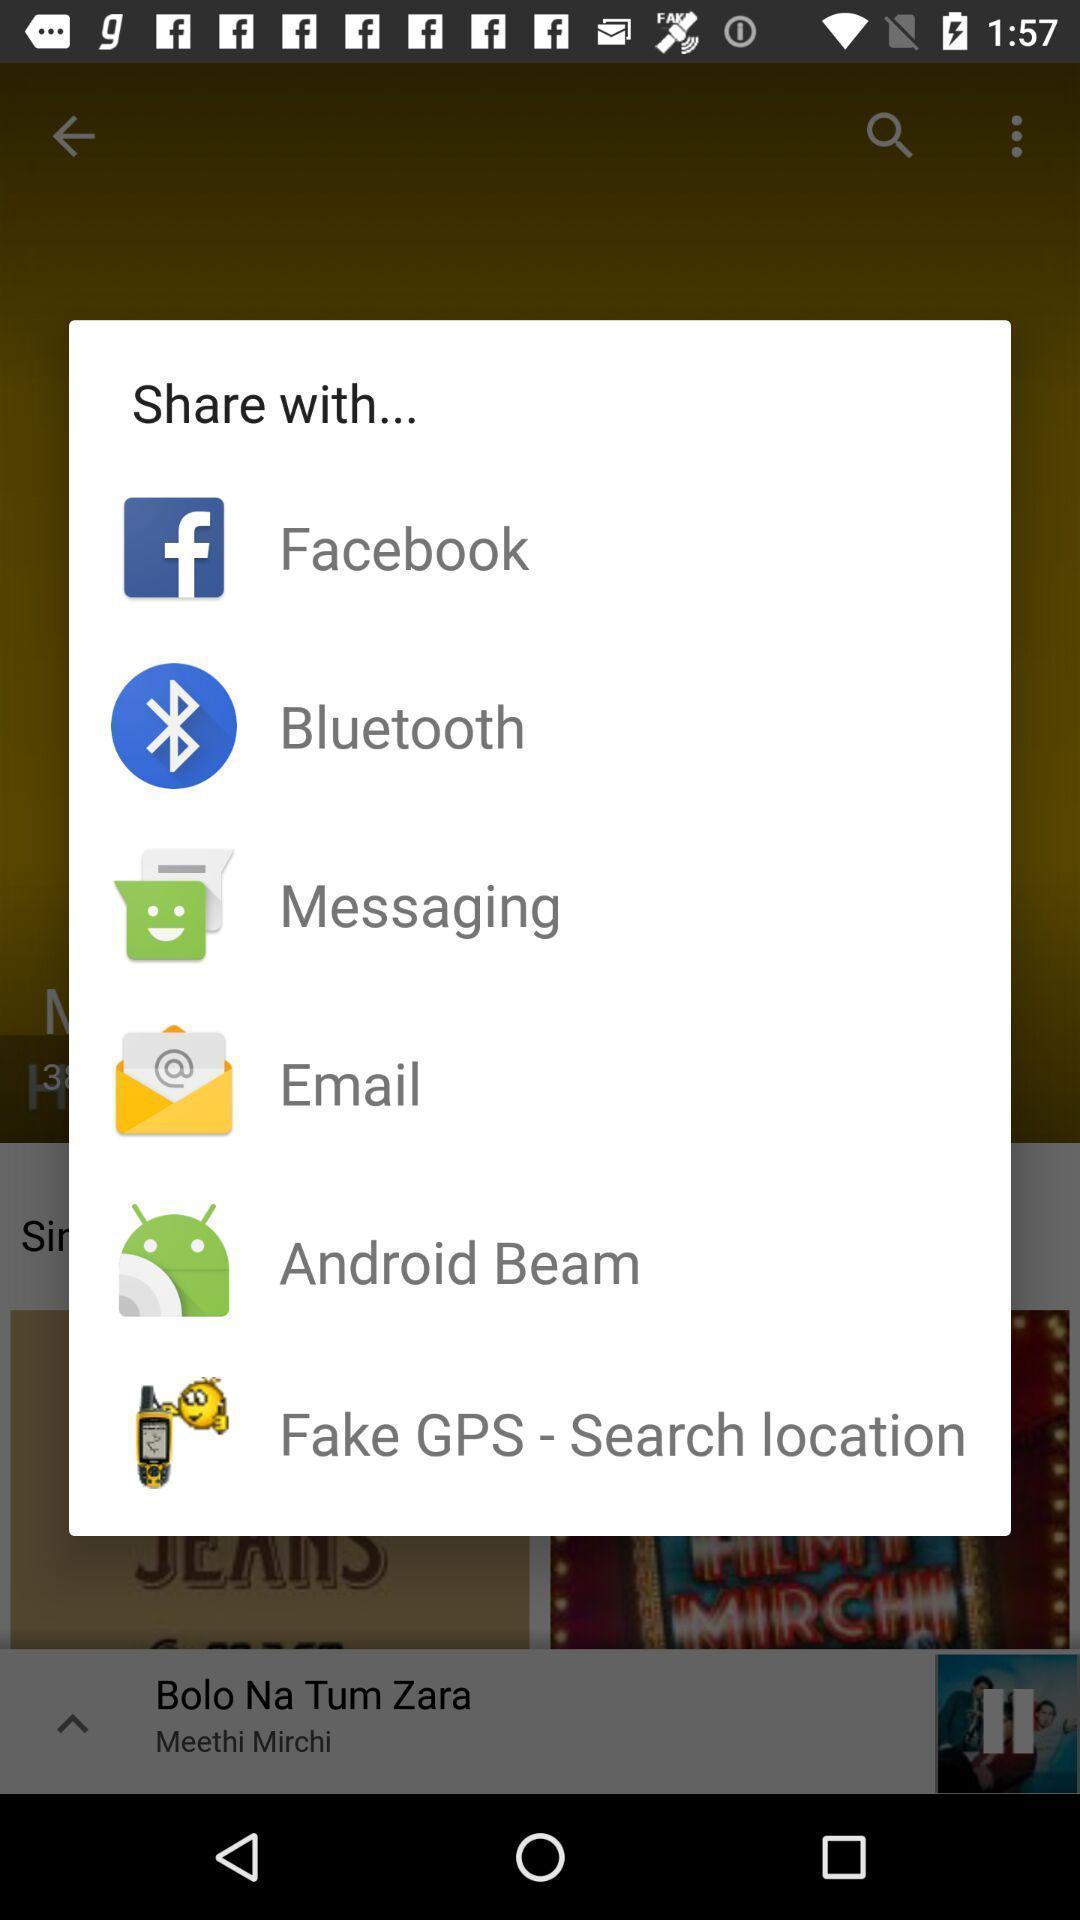Provide a textual representation of this image. Pop-up shows share option with multiple applications. 